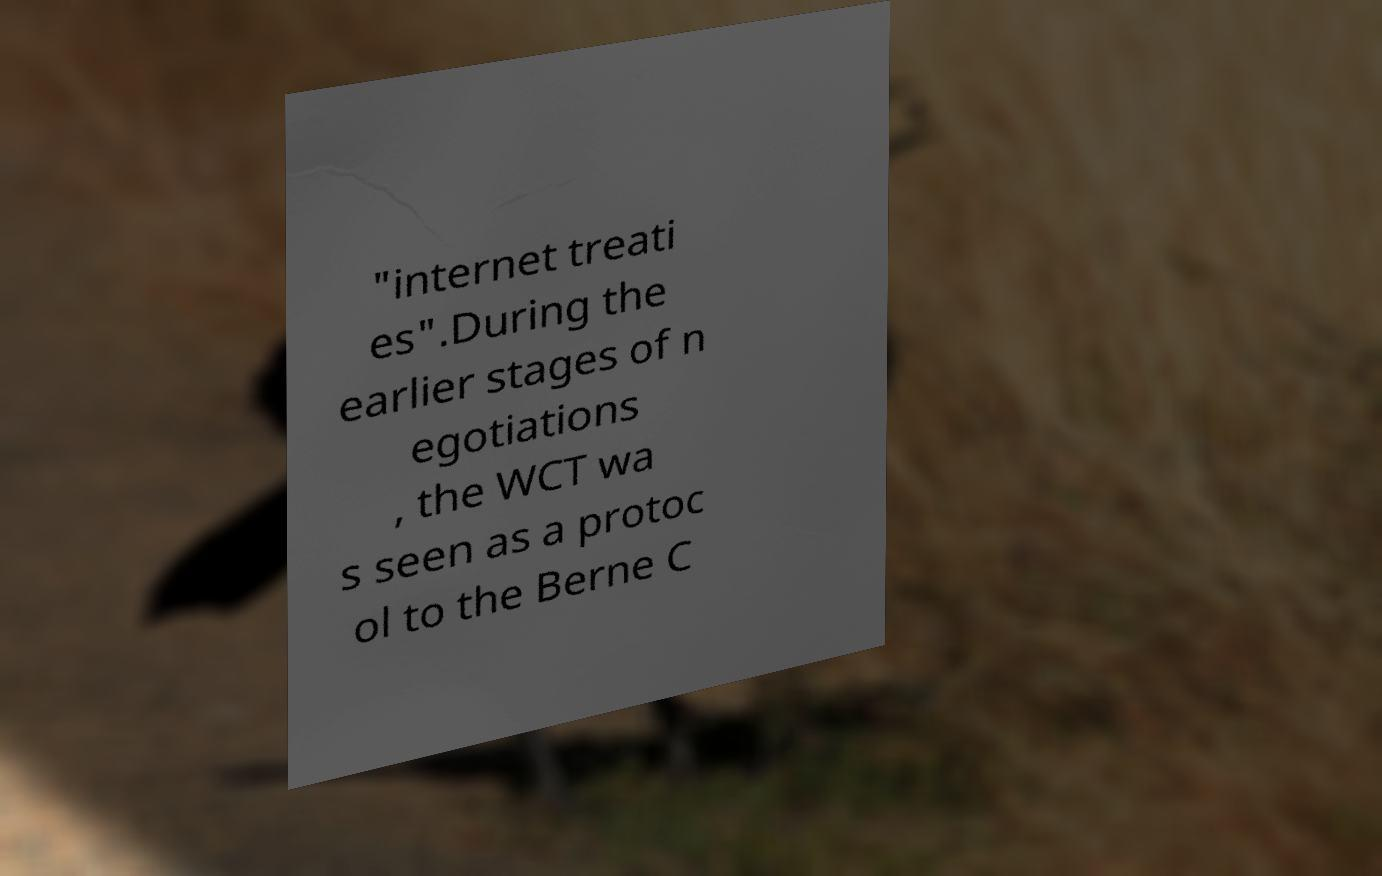For documentation purposes, I need the text within this image transcribed. Could you provide that? "internet treati es".During the earlier stages of n egotiations , the WCT wa s seen as a protoc ol to the Berne C 